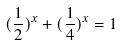<formula> <loc_0><loc_0><loc_500><loc_500>( \frac { 1 } { 2 } ) ^ { x } + ( \frac { 1 } { 4 } ) ^ { x } = 1</formula> 